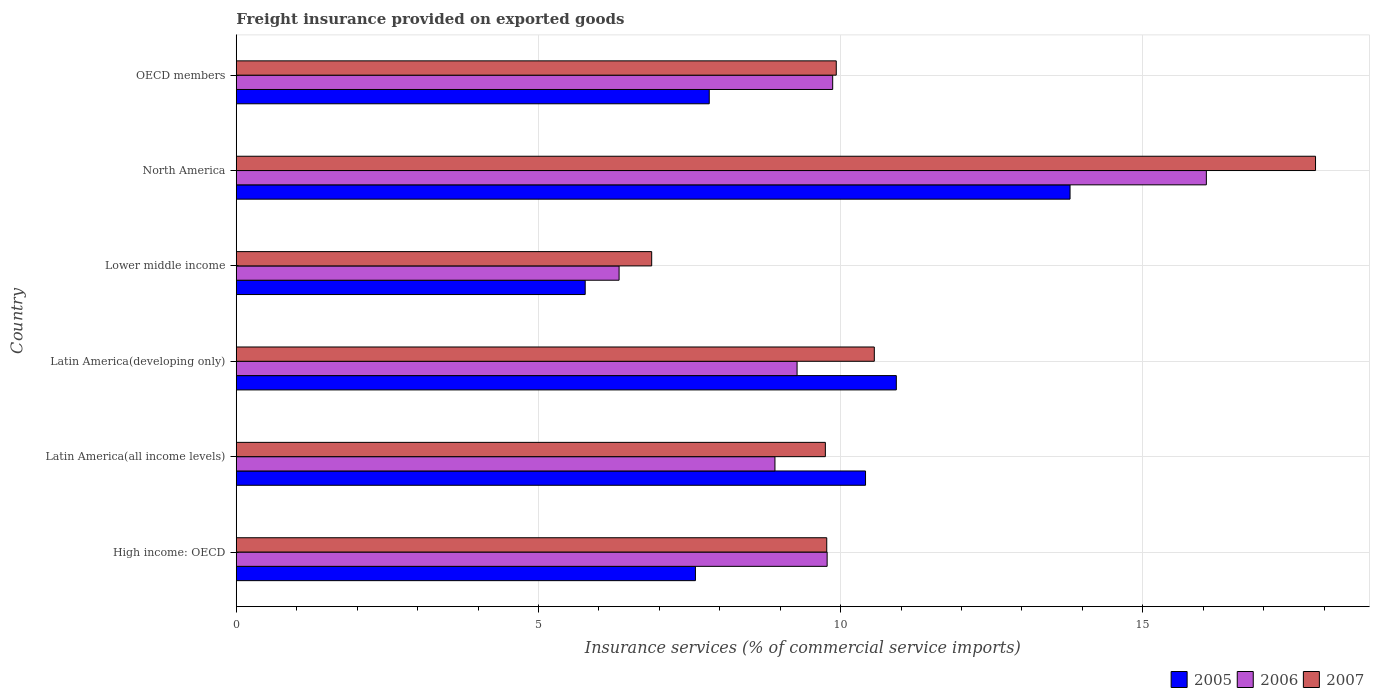Are the number of bars per tick equal to the number of legend labels?
Your answer should be compact. Yes. What is the label of the 3rd group of bars from the top?
Provide a short and direct response. Lower middle income. In how many cases, is the number of bars for a given country not equal to the number of legend labels?
Your answer should be compact. 0. What is the freight insurance provided on exported goods in 2005 in OECD members?
Make the answer very short. 7.83. Across all countries, what is the maximum freight insurance provided on exported goods in 2006?
Your answer should be very brief. 16.05. Across all countries, what is the minimum freight insurance provided on exported goods in 2007?
Make the answer very short. 6.87. In which country was the freight insurance provided on exported goods in 2005 minimum?
Offer a very short reply. Lower middle income. What is the total freight insurance provided on exported goods in 2006 in the graph?
Give a very brief answer. 60.23. What is the difference between the freight insurance provided on exported goods in 2005 in Latin America(all income levels) and that in OECD members?
Keep it short and to the point. 2.59. What is the difference between the freight insurance provided on exported goods in 2006 in North America and the freight insurance provided on exported goods in 2005 in Latin America(all income levels)?
Your answer should be very brief. 5.64. What is the average freight insurance provided on exported goods in 2007 per country?
Make the answer very short. 10.79. What is the difference between the freight insurance provided on exported goods in 2007 and freight insurance provided on exported goods in 2006 in Latin America(developing only)?
Provide a succinct answer. 1.28. What is the ratio of the freight insurance provided on exported goods in 2006 in Latin America(all income levels) to that in Latin America(developing only)?
Keep it short and to the point. 0.96. Is the freight insurance provided on exported goods in 2006 in Latin America(developing only) less than that in North America?
Offer a terse response. Yes. Is the difference between the freight insurance provided on exported goods in 2007 in Latin America(all income levels) and Lower middle income greater than the difference between the freight insurance provided on exported goods in 2006 in Latin America(all income levels) and Lower middle income?
Offer a terse response. Yes. What is the difference between the highest and the second highest freight insurance provided on exported goods in 2005?
Give a very brief answer. 2.87. What is the difference between the highest and the lowest freight insurance provided on exported goods in 2007?
Your answer should be compact. 10.98. What does the 3rd bar from the top in Lower middle income represents?
Keep it short and to the point. 2005. Is it the case that in every country, the sum of the freight insurance provided on exported goods in 2006 and freight insurance provided on exported goods in 2005 is greater than the freight insurance provided on exported goods in 2007?
Provide a short and direct response. Yes. How many bars are there?
Your answer should be very brief. 18. Are all the bars in the graph horizontal?
Make the answer very short. Yes. What is the difference between two consecutive major ticks on the X-axis?
Provide a succinct answer. 5. Are the values on the major ticks of X-axis written in scientific E-notation?
Make the answer very short. No. Does the graph contain any zero values?
Your answer should be very brief. No. Where does the legend appear in the graph?
Keep it short and to the point. Bottom right. How many legend labels are there?
Your answer should be compact. 3. How are the legend labels stacked?
Provide a succinct answer. Horizontal. What is the title of the graph?
Ensure brevity in your answer.  Freight insurance provided on exported goods. Does "2009" appear as one of the legend labels in the graph?
Make the answer very short. No. What is the label or title of the X-axis?
Keep it short and to the point. Insurance services (% of commercial service imports). What is the label or title of the Y-axis?
Offer a very short reply. Country. What is the Insurance services (% of commercial service imports) of 2005 in High income: OECD?
Give a very brief answer. 7.6. What is the Insurance services (% of commercial service imports) in 2006 in High income: OECD?
Your response must be concise. 9.78. What is the Insurance services (% of commercial service imports) of 2007 in High income: OECD?
Provide a succinct answer. 9.77. What is the Insurance services (% of commercial service imports) of 2005 in Latin America(all income levels)?
Give a very brief answer. 10.41. What is the Insurance services (% of commercial service imports) of 2006 in Latin America(all income levels)?
Keep it short and to the point. 8.91. What is the Insurance services (% of commercial service imports) of 2007 in Latin America(all income levels)?
Offer a terse response. 9.75. What is the Insurance services (% of commercial service imports) of 2005 in Latin America(developing only)?
Your response must be concise. 10.92. What is the Insurance services (% of commercial service imports) of 2006 in Latin America(developing only)?
Make the answer very short. 9.28. What is the Insurance services (% of commercial service imports) in 2007 in Latin America(developing only)?
Provide a short and direct response. 10.56. What is the Insurance services (% of commercial service imports) of 2005 in Lower middle income?
Offer a terse response. 5.77. What is the Insurance services (% of commercial service imports) in 2006 in Lower middle income?
Your answer should be compact. 6.33. What is the Insurance services (% of commercial service imports) of 2007 in Lower middle income?
Give a very brief answer. 6.87. What is the Insurance services (% of commercial service imports) in 2005 in North America?
Keep it short and to the point. 13.8. What is the Insurance services (% of commercial service imports) of 2006 in North America?
Your answer should be very brief. 16.05. What is the Insurance services (% of commercial service imports) in 2007 in North America?
Your response must be concise. 17.86. What is the Insurance services (% of commercial service imports) of 2005 in OECD members?
Provide a short and direct response. 7.83. What is the Insurance services (% of commercial service imports) of 2006 in OECD members?
Keep it short and to the point. 9.87. What is the Insurance services (% of commercial service imports) of 2007 in OECD members?
Your answer should be compact. 9.93. Across all countries, what is the maximum Insurance services (% of commercial service imports) of 2005?
Make the answer very short. 13.8. Across all countries, what is the maximum Insurance services (% of commercial service imports) in 2006?
Ensure brevity in your answer.  16.05. Across all countries, what is the maximum Insurance services (% of commercial service imports) of 2007?
Provide a succinct answer. 17.86. Across all countries, what is the minimum Insurance services (% of commercial service imports) in 2005?
Offer a very short reply. 5.77. Across all countries, what is the minimum Insurance services (% of commercial service imports) of 2006?
Provide a short and direct response. 6.33. Across all countries, what is the minimum Insurance services (% of commercial service imports) of 2007?
Make the answer very short. 6.87. What is the total Insurance services (% of commercial service imports) of 2005 in the graph?
Your answer should be compact. 56.33. What is the total Insurance services (% of commercial service imports) of 2006 in the graph?
Your answer should be very brief. 60.23. What is the total Insurance services (% of commercial service imports) in 2007 in the graph?
Your response must be concise. 64.74. What is the difference between the Insurance services (% of commercial service imports) in 2005 in High income: OECD and that in Latin America(all income levels)?
Offer a terse response. -2.81. What is the difference between the Insurance services (% of commercial service imports) of 2006 in High income: OECD and that in Latin America(all income levels)?
Make the answer very short. 0.86. What is the difference between the Insurance services (% of commercial service imports) in 2007 in High income: OECD and that in Latin America(all income levels)?
Your response must be concise. 0.02. What is the difference between the Insurance services (% of commercial service imports) in 2005 in High income: OECD and that in Latin America(developing only)?
Give a very brief answer. -3.32. What is the difference between the Insurance services (% of commercial service imports) of 2006 in High income: OECD and that in Latin America(developing only)?
Keep it short and to the point. 0.5. What is the difference between the Insurance services (% of commercial service imports) in 2007 in High income: OECD and that in Latin America(developing only)?
Your answer should be compact. -0.79. What is the difference between the Insurance services (% of commercial service imports) of 2005 in High income: OECD and that in Lower middle income?
Ensure brevity in your answer.  1.82. What is the difference between the Insurance services (% of commercial service imports) of 2006 in High income: OECD and that in Lower middle income?
Give a very brief answer. 3.44. What is the difference between the Insurance services (% of commercial service imports) of 2007 in High income: OECD and that in Lower middle income?
Your response must be concise. 2.9. What is the difference between the Insurance services (% of commercial service imports) in 2005 in High income: OECD and that in North America?
Offer a very short reply. -6.2. What is the difference between the Insurance services (% of commercial service imports) of 2006 in High income: OECD and that in North America?
Provide a short and direct response. -6.27. What is the difference between the Insurance services (% of commercial service imports) of 2007 in High income: OECD and that in North America?
Provide a succinct answer. -8.09. What is the difference between the Insurance services (% of commercial service imports) of 2005 in High income: OECD and that in OECD members?
Make the answer very short. -0.23. What is the difference between the Insurance services (% of commercial service imports) of 2006 in High income: OECD and that in OECD members?
Ensure brevity in your answer.  -0.09. What is the difference between the Insurance services (% of commercial service imports) in 2007 in High income: OECD and that in OECD members?
Provide a succinct answer. -0.16. What is the difference between the Insurance services (% of commercial service imports) of 2005 in Latin America(all income levels) and that in Latin America(developing only)?
Keep it short and to the point. -0.51. What is the difference between the Insurance services (% of commercial service imports) of 2006 in Latin America(all income levels) and that in Latin America(developing only)?
Your response must be concise. -0.37. What is the difference between the Insurance services (% of commercial service imports) in 2007 in Latin America(all income levels) and that in Latin America(developing only)?
Give a very brief answer. -0.81. What is the difference between the Insurance services (% of commercial service imports) in 2005 in Latin America(all income levels) and that in Lower middle income?
Provide a succinct answer. 4.64. What is the difference between the Insurance services (% of commercial service imports) of 2006 in Latin America(all income levels) and that in Lower middle income?
Your answer should be very brief. 2.58. What is the difference between the Insurance services (% of commercial service imports) of 2007 in Latin America(all income levels) and that in Lower middle income?
Your answer should be very brief. 2.87. What is the difference between the Insurance services (% of commercial service imports) in 2005 in Latin America(all income levels) and that in North America?
Ensure brevity in your answer.  -3.38. What is the difference between the Insurance services (% of commercial service imports) in 2006 in Latin America(all income levels) and that in North America?
Provide a succinct answer. -7.14. What is the difference between the Insurance services (% of commercial service imports) in 2007 in Latin America(all income levels) and that in North America?
Provide a succinct answer. -8.11. What is the difference between the Insurance services (% of commercial service imports) in 2005 in Latin America(all income levels) and that in OECD members?
Offer a very short reply. 2.59. What is the difference between the Insurance services (% of commercial service imports) of 2006 in Latin America(all income levels) and that in OECD members?
Provide a succinct answer. -0.96. What is the difference between the Insurance services (% of commercial service imports) of 2007 in Latin America(all income levels) and that in OECD members?
Give a very brief answer. -0.18. What is the difference between the Insurance services (% of commercial service imports) in 2005 in Latin America(developing only) and that in Lower middle income?
Offer a very short reply. 5.15. What is the difference between the Insurance services (% of commercial service imports) of 2006 in Latin America(developing only) and that in Lower middle income?
Ensure brevity in your answer.  2.95. What is the difference between the Insurance services (% of commercial service imports) of 2007 in Latin America(developing only) and that in Lower middle income?
Offer a terse response. 3.68. What is the difference between the Insurance services (% of commercial service imports) in 2005 in Latin America(developing only) and that in North America?
Your answer should be very brief. -2.87. What is the difference between the Insurance services (% of commercial service imports) of 2006 in Latin America(developing only) and that in North America?
Provide a short and direct response. -6.77. What is the difference between the Insurance services (% of commercial service imports) in 2007 in Latin America(developing only) and that in North America?
Ensure brevity in your answer.  -7.3. What is the difference between the Insurance services (% of commercial service imports) of 2005 in Latin America(developing only) and that in OECD members?
Provide a short and direct response. 3.1. What is the difference between the Insurance services (% of commercial service imports) of 2006 in Latin America(developing only) and that in OECD members?
Give a very brief answer. -0.59. What is the difference between the Insurance services (% of commercial service imports) in 2007 in Latin America(developing only) and that in OECD members?
Provide a succinct answer. 0.63. What is the difference between the Insurance services (% of commercial service imports) in 2005 in Lower middle income and that in North America?
Your response must be concise. -8.02. What is the difference between the Insurance services (% of commercial service imports) in 2006 in Lower middle income and that in North America?
Provide a short and direct response. -9.72. What is the difference between the Insurance services (% of commercial service imports) in 2007 in Lower middle income and that in North America?
Provide a short and direct response. -10.98. What is the difference between the Insurance services (% of commercial service imports) of 2005 in Lower middle income and that in OECD members?
Your answer should be very brief. -2.05. What is the difference between the Insurance services (% of commercial service imports) in 2006 in Lower middle income and that in OECD members?
Keep it short and to the point. -3.53. What is the difference between the Insurance services (% of commercial service imports) in 2007 in Lower middle income and that in OECD members?
Give a very brief answer. -3.05. What is the difference between the Insurance services (% of commercial service imports) of 2005 in North America and that in OECD members?
Your response must be concise. 5.97. What is the difference between the Insurance services (% of commercial service imports) in 2006 in North America and that in OECD members?
Offer a terse response. 6.18. What is the difference between the Insurance services (% of commercial service imports) in 2007 in North America and that in OECD members?
Make the answer very short. 7.93. What is the difference between the Insurance services (% of commercial service imports) in 2005 in High income: OECD and the Insurance services (% of commercial service imports) in 2006 in Latin America(all income levels)?
Offer a very short reply. -1.32. What is the difference between the Insurance services (% of commercial service imports) of 2005 in High income: OECD and the Insurance services (% of commercial service imports) of 2007 in Latin America(all income levels)?
Provide a succinct answer. -2.15. What is the difference between the Insurance services (% of commercial service imports) in 2006 in High income: OECD and the Insurance services (% of commercial service imports) in 2007 in Latin America(all income levels)?
Offer a very short reply. 0.03. What is the difference between the Insurance services (% of commercial service imports) of 2005 in High income: OECD and the Insurance services (% of commercial service imports) of 2006 in Latin America(developing only)?
Your response must be concise. -1.68. What is the difference between the Insurance services (% of commercial service imports) of 2005 in High income: OECD and the Insurance services (% of commercial service imports) of 2007 in Latin America(developing only)?
Your response must be concise. -2.96. What is the difference between the Insurance services (% of commercial service imports) in 2006 in High income: OECD and the Insurance services (% of commercial service imports) in 2007 in Latin America(developing only)?
Your answer should be very brief. -0.78. What is the difference between the Insurance services (% of commercial service imports) of 2005 in High income: OECD and the Insurance services (% of commercial service imports) of 2006 in Lower middle income?
Provide a succinct answer. 1.26. What is the difference between the Insurance services (% of commercial service imports) in 2005 in High income: OECD and the Insurance services (% of commercial service imports) in 2007 in Lower middle income?
Your response must be concise. 0.72. What is the difference between the Insurance services (% of commercial service imports) in 2006 in High income: OECD and the Insurance services (% of commercial service imports) in 2007 in Lower middle income?
Your response must be concise. 2.9. What is the difference between the Insurance services (% of commercial service imports) of 2005 in High income: OECD and the Insurance services (% of commercial service imports) of 2006 in North America?
Your answer should be very brief. -8.45. What is the difference between the Insurance services (% of commercial service imports) of 2005 in High income: OECD and the Insurance services (% of commercial service imports) of 2007 in North America?
Ensure brevity in your answer.  -10.26. What is the difference between the Insurance services (% of commercial service imports) of 2006 in High income: OECD and the Insurance services (% of commercial service imports) of 2007 in North America?
Your answer should be compact. -8.08. What is the difference between the Insurance services (% of commercial service imports) of 2005 in High income: OECD and the Insurance services (% of commercial service imports) of 2006 in OECD members?
Provide a succinct answer. -2.27. What is the difference between the Insurance services (% of commercial service imports) in 2005 in High income: OECD and the Insurance services (% of commercial service imports) in 2007 in OECD members?
Offer a very short reply. -2.33. What is the difference between the Insurance services (% of commercial service imports) in 2006 in High income: OECD and the Insurance services (% of commercial service imports) in 2007 in OECD members?
Offer a terse response. -0.15. What is the difference between the Insurance services (% of commercial service imports) of 2005 in Latin America(all income levels) and the Insurance services (% of commercial service imports) of 2006 in Latin America(developing only)?
Keep it short and to the point. 1.13. What is the difference between the Insurance services (% of commercial service imports) in 2005 in Latin America(all income levels) and the Insurance services (% of commercial service imports) in 2007 in Latin America(developing only)?
Ensure brevity in your answer.  -0.15. What is the difference between the Insurance services (% of commercial service imports) of 2006 in Latin America(all income levels) and the Insurance services (% of commercial service imports) of 2007 in Latin America(developing only)?
Provide a succinct answer. -1.64. What is the difference between the Insurance services (% of commercial service imports) of 2005 in Latin America(all income levels) and the Insurance services (% of commercial service imports) of 2006 in Lower middle income?
Offer a very short reply. 4.08. What is the difference between the Insurance services (% of commercial service imports) of 2005 in Latin America(all income levels) and the Insurance services (% of commercial service imports) of 2007 in Lower middle income?
Your answer should be very brief. 3.54. What is the difference between the Insurance services (% of commercial service imports) of 2006 in Latin America(all income levels) and the Insurance services (% of commercial service imports) of 2007 in Lower middle income?
Provide a succinct answer. 2.04. What is the difference between the Insurance services (% of commercial service imports) in 2005 in Latin America(all income levels) and the Insurance services (% of commercial service imports) in 2006 in North America?
Your response must be concise. -5.64. What is the difference between the Insurance services (% of commercial service imports) of 2005 in Latin America(all income levels) and the Insurance services (% of commercial service imports) of 2007 in North America?
Your response must be concise. -7.45. What is the difference between the Insurance services (% of commercial service imports) in 2006 in Latin America(all income levels) and the Insurance services (% of commercial service imports) in 2007 in North America?
Give a very brief answer. -8.94. What is the difference between the Insurance services (% of commercial service imports) in 2005 in Latin America(all income levels) and the Insurance services (% of commercial service imports) in 2006 in OECD members?
Your answer should be very brief. 0.54. What is the difference between the Insurance services (% of commercial service imports) of 2005 in Latin America(all income levels) and the Insurance services (% of commercial service imports) of 2007 in OECD members?
Your answer should be compact. 0.48. What is the difference between the Insurance services (% of commercial service imports) in 2006 in Latin America(all income levels) and the Insurance services (% of commercial service imports) in 2007 in OECD members?
Your answer should be compact. -1.01. What is the difference between the Insurance services (% of commercial service imports) of 2005 in Latin America(developing only) and the Insurance services (% of commercial service imports) of 2006 in Lower middle income?
Give a very brief answer. 4.59. What is the difference between the Insurance services (% of commercial service imports) in 2005 in Latin America(developing only) and the Insurance services (% of commercial service imports) in 2007 in Lower middle income?
Give a very brief answer. 4.05. What is the difference between the Insurance services (% of commercial service imports) of 2006 in Latin America(developing only) and the Insurance services (% of commercial service imports) of 2007 in Lower middle income?
Give a very brief answer. 2.41. What is the difference between the Insurance services (% of commercial service imports) of 2005 in Latin America(developing only) and the Insurance services (% of commercial service imports) of 2006 in North America?
Offer a very short reply. -5.13. What is the difference between the Insurance services (% of commercial service imports) in 2005 in Latin America(developing only) and the Insurance services (% of commercial service imports) in 2007 in North America?
Offer a very short reply. -6.94. What is the difference between the Insurance services (% of commercial service imports) in 2006 in Latin America(developing only) and the Insurance services (% of commercial service imports) in 2007 in North America?
Provide a succinct answer. -8.58. What is the difference between the Insurance services (% of commercial service imports) in 2005 in Latin America(developing only) and the Insurance services (% of commercial service imports) in 2006 in OECD members?
Make the answer very short. 1.05. What is the difference between the Insurance services (% of commercial service imports) of 2006 in Latin America(developing only) and the Insurance services (% of commercial service imports) of 2007 in OECD members?
Give a very brief answer. -0.65. What is the difference between the Insurance services (% of commercial service imports) of 2005 in Lower middle income and the Insurance services (% of commercial service imports) of 2006 in North America?
Provide a short and direct response. -10.28. What is the difference between the Insurance services (% of commercial service imports) of 2005 in Lower middle income and the Insurance services (% of commercial service imports) of 2007 in North America?
Provide a succinct answer. -12.08. What is the difference between the Insurance services (% of commercial service imports) of 2006 in Lower middle income and the Insurance services (% of commercial service imports) of 2007 in North America?
Give a very brief answer. -11.52. What is the difference between the Insurance services (% of commercial service imports) of 2005 in Lower middle income and the Insurance services (% of commercial service imports) of 2006 in OECD members?
Provide a short and direct response. -4.1. What is the difference between the Insurance services (% of commercial service imports) in 2005 in Lower middle income and the Insurance services (% of commercial service imports) in 2007 in OECD members?
Provide a short and direct response. -4.15. What is the difference between the Insurance services (% of commercial service imports) of 2006 in Lower middle income and the Insurance services (% of commercial service imports) of 2007 in OECD members?
Make the answer very short. -3.59. What is the difference between the Insurance services (% of commercial service imports) of 2005 in North America and the Insurance services (% of commercial service imports) of 2006 in OECD members?
Your answer should be very brief. 3.93. What is the difference between the Insurance services (% of commercial service imports) of 2005 in North America and the Insurance services (% of commercial service imports) of 2007 in OECD members?
Ensure brevity in your answer.  3.87. What is the difference between the Insurance services (% of commercial service imports) in 2006 in North America and the Insurance services (% of commercial service imports) in 2007 in OECD members?
Give a very brief answer. 6.12. What is the average Insurance services (% of commercial service imports) in 2005 per country?
Ensure brevity in your answer.  9.39. What is the average Insurance services (% of commercial service imports) of 2006 per country?
Offer a terse response. 10.04. What is the average Insurance services (% of commercial service imports) of 2007 per country?
Make the answer very short. 10.79. What is the difference between the Insurance services (% of commercial service imports) in 2005 and Insurance services (% of commercial service imports) in 2006 in High income: OECD?
Offer a terse response. -2.18. What is the difference between the Insurance services (% of commercial service imports) in 2005 and Insurance services (% of commercial service imports) in 2007 in High income: OECD?
Make the answer very short. -2.17. What is the difference between the Insurance services (% of commercial service imports) of 2006 and Insurance services (% of commercial service imports) of 2007 in High income: OECD?
Your response must be concise. 0.01. What is the difference between the Insurance services (% of commercial service imports) of 2005 and Insurance services (% of commercial service imports) of 2006 in Latin America(all income levels)?
Make the answer very short. 1.5. What is the difference between the Insurance services (% of commercial service imports) in 2005 and Insurance services (% of commercial service imports) in 2007 in Latin America(all income levels)?
Give a very brief answer. 0.66. What is the difference between the Insurance services (% of commercial service imports) in 2006 and Insurance services (% of commercial service imports) in 2007 in Latin America(all income levels)?
Your answer should be very brief. -0.83. What is the difference between the Insurance services (% of commercial service imports) in 2005 and Insurance services (% of commercial service imports) in 2006 in Latin America(developing only)?
Provide a succinct answer. 1.64. What is the difference between the Insurance services (% of commercial service imports) of 2005 and Insurance services (% of commercial service imports) of 2007 in Latin America(developing only)?
Offer a terse response. 0.36. What is the difference between the Insurance services (% of commercial service imports) in 2006 and Insurance services (% of commercial service imports) in 2007 in Latin America(developing only)?
Provide a succinct answer. -1.28. What is the difference between the Insurance services (% of commercial service imports) in 2005 and Insurance services (% of commercial service imports) in 2006 in Lower middle income?
Offer a very short reply. -0.56. What is the difference between the Insurance services (% of commercial service imports) of 2005 and Insurance services (% of commercial service imports) of 2007 in Lower middle income?
Offer a very short reply. -1.1. What is the difference between the Insurance services (% of commercial service imports) of 2006 and Insurance services (% of commercial service imports) of 2007 in Lower middle income?
Keep it short and to the point. -0.54. What is the difference between the Insurance services (% of commercial service imports) of 2005 and Insurance services (% of commercial service imports) of 2006 in North America?
Your answer should be compact. -2.26. What is the difference between the Insurance services (% of commercial service imports) of 2005 and Insurance services (% of commercial service imports) of 2007 in North America?
Offer a very short reply. -4.06. What is the difference between the Insurance services (% of commercial service imports) of 2006 and Insurance services (% of commercial service imports) of 2007 in North America?
Your answer should be very brief. -1.81. What is the difference between the Insurance services (% of commercial service imports) of 2005 and Insurance services (% of commercial service imports) of 2006 in OECD members?
Your answer should be compact. -2.04. What is the difference between the Insurance services (% of commercial service imports) of 2005 and Insurance services (% of commercial service imports) of 2007 in OECD members?
Give a very brief answer. -2.1. What is the difference between the Insurance services (% of commercial service imports) in 2006 and Insurance services (% of commercial service imports) in 2007 in OECD members?
Give a very brief answer. -0.06. What is the ratio of the Insurance services (% of commercial service imports) of 2005 in High income: OECD to that in Latin America(all income levels)?
Keep it short and to the point. 0.73. What is the ratio of the Insurance services (% of commercial service imports) of 2006 in High income: OECD to that in Latin America(all income levels)?
Give a very brief answer. 1.1. What is the ratio of the Insurance services (% of commercial service imports) of 2007 in High income: OECD to that in Latin America(all income levels)?
Your answer should be very brief. 1. What is the ratio of the Insurance services (% of commercial service imports) in 2005 in High income: OECD to that in Latin America(developing only)?
Your answer should be compact. 0.7. What is the ratio of the Insurance services (% of commercial service imports) of 2006 in High income: OECD to that in Latin America(developing only)?
Make the answer very short. 1.05. What is the ratio of the Insurance services (% of commercial service imports) of 2007 in High income: OECD to that in Latin America(developing only)?
Ensure brevity in your answer.  0.93. What is the ratio of the Insurance services (% of commercial service imports) of 2005 in High income: OECD to that in Lower middle income?
Provide a short and direct response. 1.32. What is the ratio of the Insurance services (% of commercial service imports) in 2006 in High income: OECD to that in Lower middle income?
Keep it short and to the point. 1.54. What is the ratio of the Insurance services (% of commercial service imports) of 2007 in High income: OECD to that in Lower middle income?
Give a very brief answer. 1.42. What is the ratio of the Insurance services (% of commercial service imports) in 2005 in High income: OECD to that in North America?
Ensure brevity in your answer.  0.55. What is the ratio of the Insurance services (% of commercial service imports) in 2006 in High income: OECD to that in North America?
Keep it short and to the point. 0.61. What is the ratio of the Insurance services (% of commercial service imports) of 2007 in High income: OECD to that in North America?
Ensure brevity in your answer.  0.55. What is the ratio of the Insurance services (% of commercial service imports) in 2005 in High income: OECD to that in OECD members?
Offer a terse response. 0.97. What is the ratio of the Insurance services (% of commercial service imports) in 2006 in High income: OECD to that in OECD members?
Keep it short and to the point. 0.99. What is the ratio of the Insurance services (% of commercial service imports) in 2007 in High income: OECD to that in OECD members?
Give a very brief answer. 0.98. What is the ratio of the Insurance services (% of commercial service imports) of 2005 in Latin America(all income levels) to that in Latin America(developing only)?
Offer a very short reply. 0.95. What is the ratio of the Insurance services (% of commercial service imports) in 2006 in Latin America(all income levels) to that in Latin America(developing only)?
Provide a succinct answer. 0.96. What is the ratio of the Insurance services (% of commercial service imports) in 2007 in Latin America(all income levels) to that in Latin America(developing only)?
Your response must be concise. 0.92. What is the ratio of the Insurance services (% of commercial service imports) of 2005 in Latin America(all income levels) to that in Lower middle income?
Your answer should be very brief. 1.8. What is the ratio of the Insurance services (% of commercial service imports) in 2006 in Latin America(all income levels) to that in Lower middle income?
Make the answer very short. 1.41. What is the ratio of the Insurance services (% of commercial service imports) of 2007 in Latin America(all income levels) to that in Lower middle income?
Offer a terse response. 1.42. What is the ratio of the Insurance services (% of commercial service imports) of 2005 in Latin America(all income levels) to that in North America?
Offer a very short reply. 0.75. What is the ratio of the Insurance services (% of commercial service imports) of 2006 in Latin America(all income levels) to that in North America?
Provide a short and direct response. 0.56. What is the ratio of the Insurance services (% of commercial service imports) of 2007 in Latin America(all income levels) to that in North America?
Offer a terse response. 0.55. What is the ratio of the Insurance services (% of commercial service imports) in 2005 in Latin America(all income levels) to that in OECD members?
Ensure brevity in your answer.  1.33. What is the ratio of the Insurance services (% of commercial service imports) in 2006 in Latin America(all income levels) to that in OECD members?
Your answer should be compact. 0.9. What is the ratio of the Insurance services (% of commercial service imports) of 2007 in Latin America(all income levels) to that in OECD members?
Offer a terse response. 0.98. What is the ratio of the Insurance services (% of commercial service imports) in 2005 in Latin America(developing only) to that in Lower middle income?
Ensure brevity in your answer.  1.89. What is the ratio of the Insurance services (% of commercial service imports) of 2006 in Latin America(developing only) to that in Lower middle income?
Provide a short and direct response. 1.46. What is the ratio of the Insurance services (% of commercial service imports) in 2007 in Latin America(developing only) to that in Lower middle income?
Your answer should be compact. 1.54. What is the ratio of the Insurance services (% of commercial service imports) in 2005 in Latin America(developing only) to that in North America?
Keep it short and to the point. 0.79. What is the ratio of the Insurance services (% of commercial service imports) in 2006 in Latin America(developing only) to that in North America?
Give a very brief answer. 0.58. What is the ratio of the Insurance services (% of commercial service imports) in 2007 in Latin America(developing only) to that in North America?
Give a very brief answer. 0.59. What is the ratio of the Insurance services (% of commercial service imports) of 2005 in Latin America(developing only) to that in OECD members?
Offer a terse response. 1.4. What is the ratio of the Insurance services (% of commercial service imports) in 2006 in Latin America(developing only) to that in OECD members?
Make the answer very short. 0.94. What is the ratio of the Insurance services (% of commercial service imports) in 2007 in Latin America(developing only) to that in OECD members?
Make the answer very short. 1.06. What is the ratio of the Insurance services (% of commercial service imports) in 2005 in Lower middle income to that in North America?
Offer a very short reply. 0.42. What is the ratio of the Insurance services (% of commercial service imports) in 2006 in Lower middle income to that in North America?
Ensure brevity in your answer.  0.39. What is the ratio of the Insurance services (% of commercial service imports) of 2007 in Lower middle income to that in North America?
Provide a succinct answer. 0.38. What is the ratio of the Insurance services (% of commercial service imports) in 2005 in Lower middle income to that in OECD members?
Your answer should be very brief. 0.74. What is the ratio of the Insurance services (% of commercial service imports) of 2006 in Lower middle income to that in OECD members?
Your response must be concise. 0.64. What is the ratio of the Insurance services (% of commercial service imports) in 2007 in Lower middle income to that in OECD members?
Give a very brief answer. 0.69. What is the ratio of the Insurance services (% of commercial service imports) of 2005 in North America to that in OECD members?
Provide a short and direct response. 1.76. What is the ratio of the Insurance services (% of commercial service imports) in 2006 in North America to that in OECD members?
Give a very brief answer. 1.63. What is the ratio of the Insurance services (% of commercial service imports) of 2007 in North America to that in OECD members?
Your response must be concise. 1.8. What is the difference between the highest and the second highest Insurance services (% of commercial service imports) in 2005?
Your answer should be very brief. 2.87. What is the difference between the highest and the second highest Insurance services (% of commercial service imports) of 2006?
Your response must be concise. 6.18. What is the difference between the highest and the second highest Insurance services (% of commercial service imports) of 2007?
Your answer should be compact. 7.3. What is the difference between the highest and the lowest Insurance services (% of commercial service imports) in 2005?
Offer a very short reply. 8.02. What is the difference between the highest and the lowest Insurance services (% of commercial service imports) of 2006?
Your answer should be very brief. 9.72. What is the difference between the highest and the lowest Insurance services (% of commercial service imports) in 2007?
Your answer should be very brief. 10.98. 